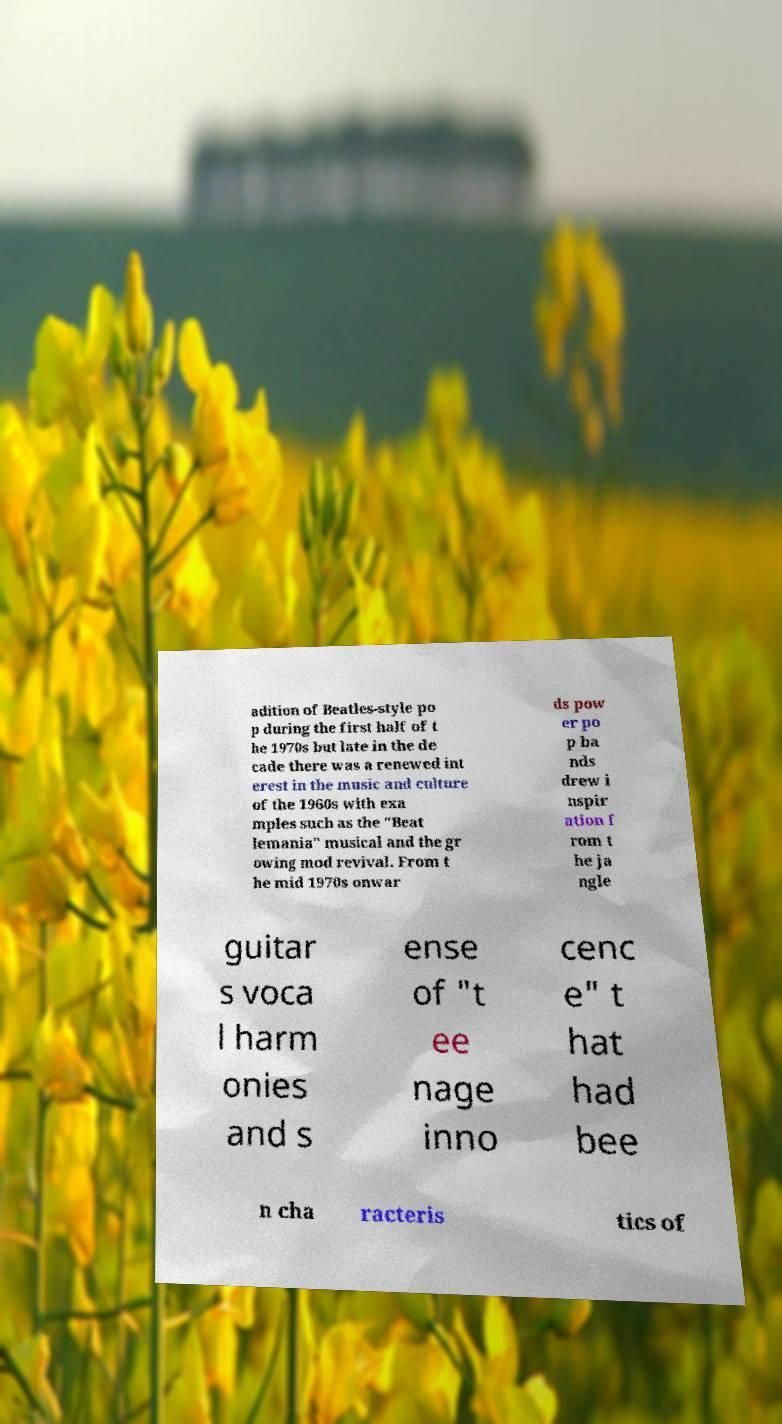For documentation purposes, I need the text within this image transcribed. Could you provide that? adition of Beatles-style po p during the first half of t he 1970s but late in the de cade there was a renewed int erest in the music and culture of the 1960s with exa mples such as the "Beat lemania" musical and the gr owing mod revival. From t he mid 1970s onwar ds pow er po p ba nds drew i nspir ation f rom t he ja ngle guitar s voca l harm onies and s ense of "t ee nage inno cenc e" t hat had bee n cha racteris tics of 